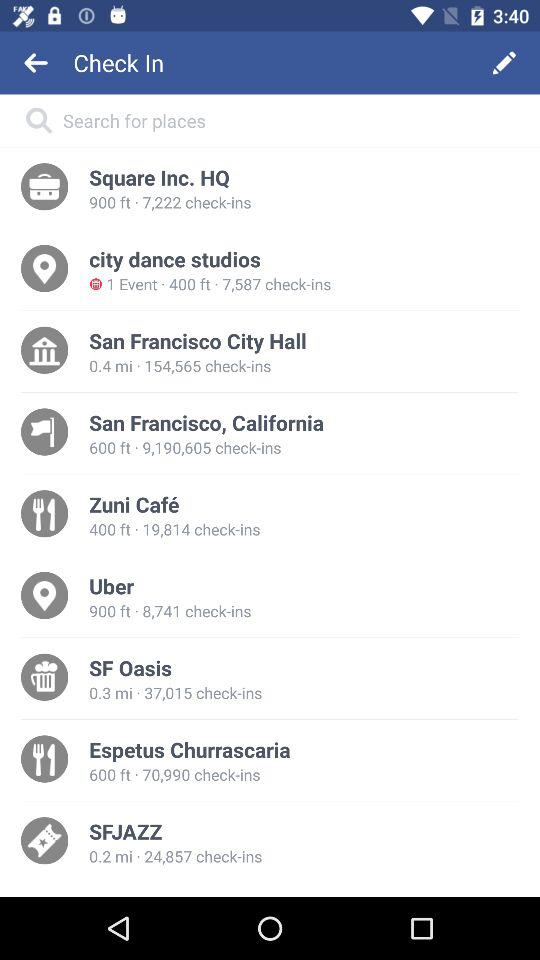What place is having an event? The place having an event is "city dance studios". 